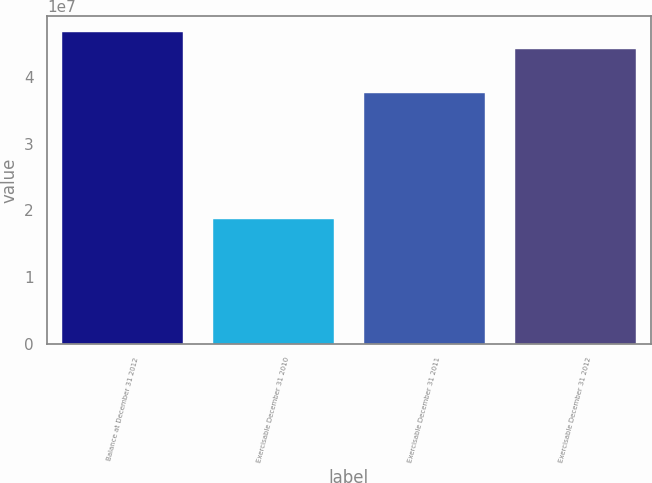Convert chart to OTSL. <chart><loc_0><loc_0><loc_500><loc_500><bar_chart><fcel>Balance at December 31 2012<fcel>Exercisable December 31 2010<fcel>Exercisable December 31 2011<fcel>Exercisable December 31 2012<nl><fcel>4.67275e+07<fcel>1.8684e+07<fcel>3.75265e+07<fcel>4.41767e+07<nl></chart> 